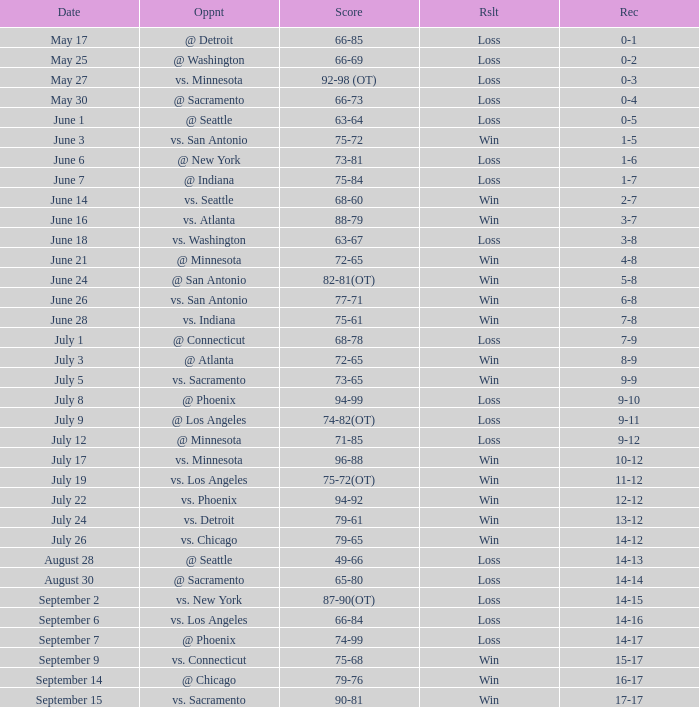What was the Result on July 24? Win. 